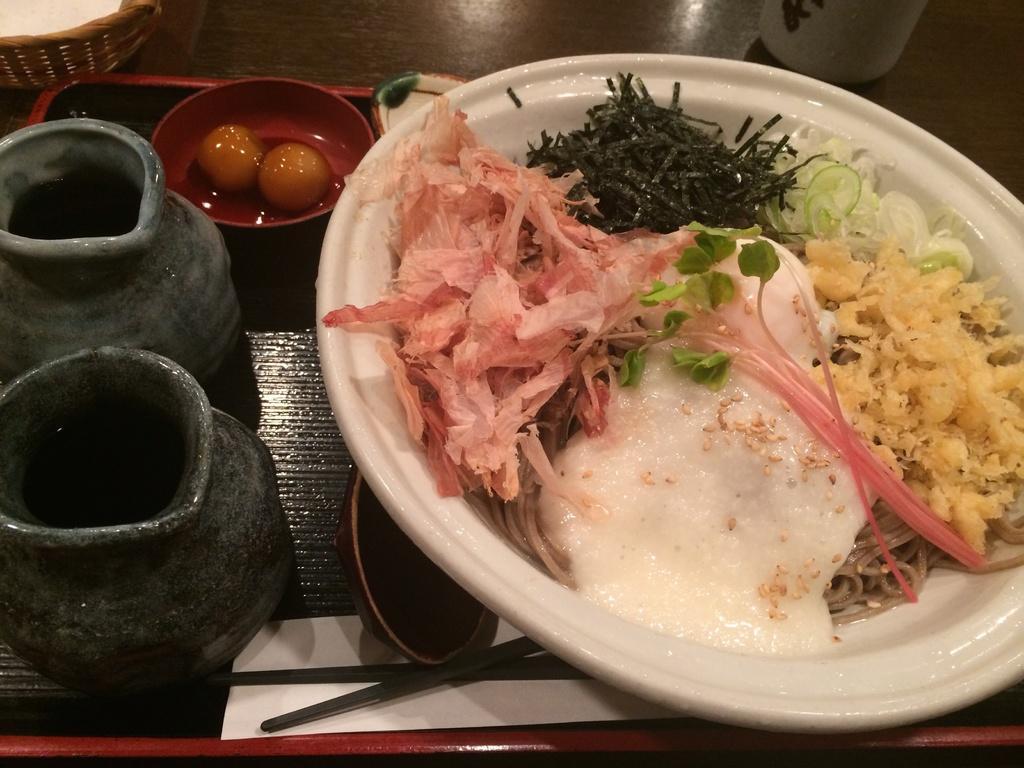Describe this image in one or two sentences. In this image we can see a serving which consists of serving plate with food on it, a bowl with egg yolks on it and cutlery. 